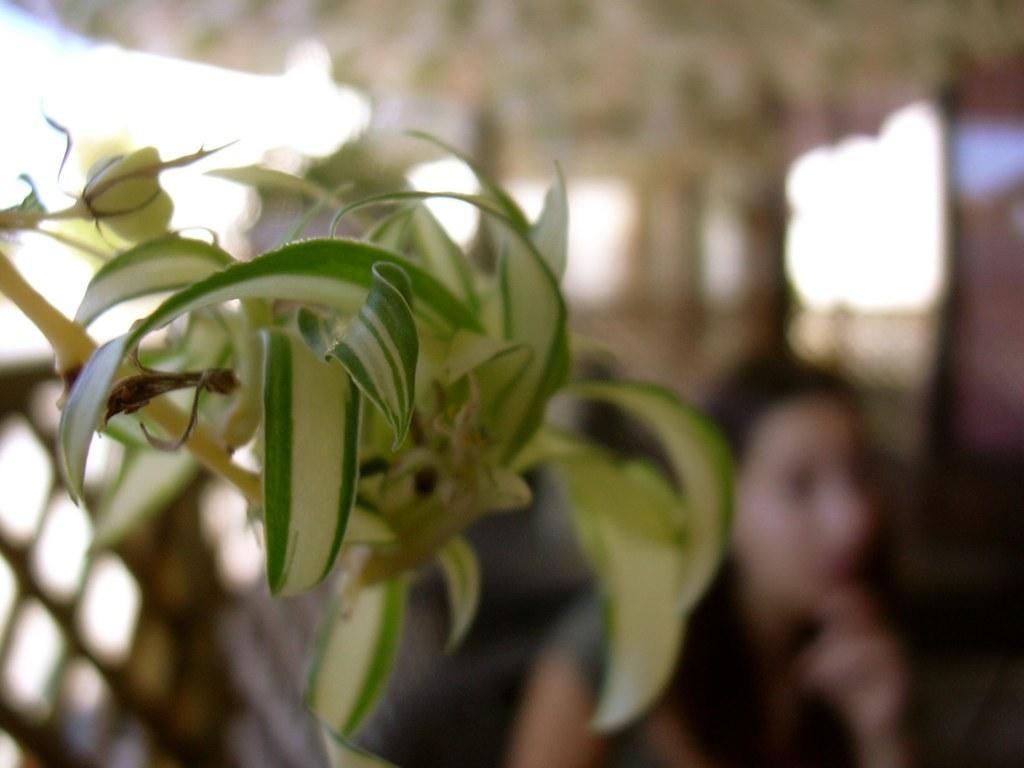How would you summarize this image in a sentence or two? In this picture we can see a blue image, we can see plant and behind we can see a woman. 